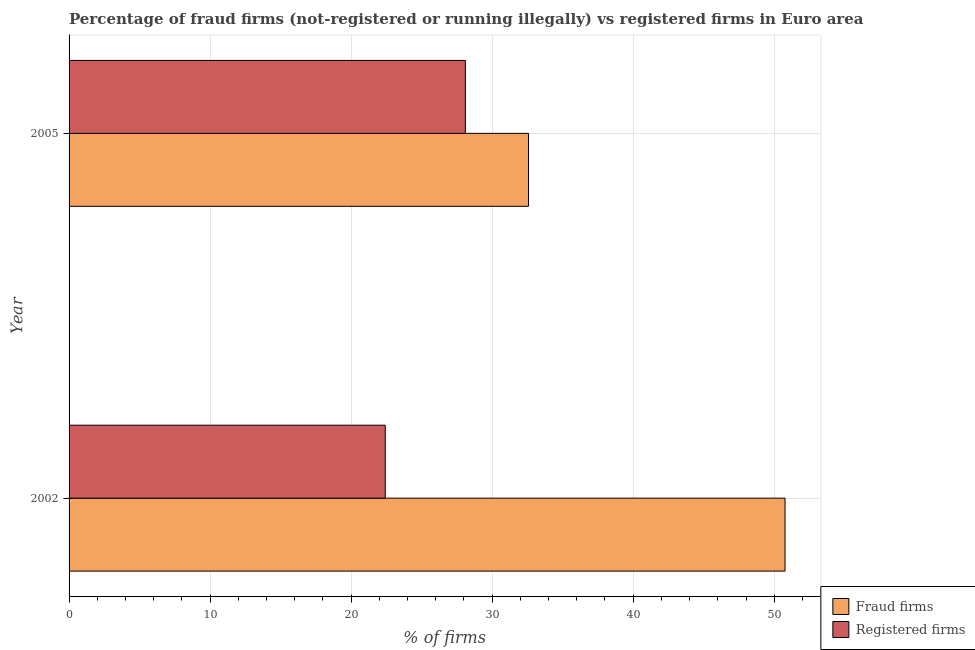How many groups of bars are there?
Give a very brief answer. 2. How many bars are there on the 1st tick from the bottom?
Provide a short and direct response. 2. In how many cases, is the number of bars for a given year not equal to the number of legend labels?
Provide a succinct answer. 0. What is the percentage of fraud firms in 2002?
Offer a very short reply. 50.77. Across all years, what is the maximum percentage of fraud firms?
Provide a succinct answer. 50.77. Across all years, what is the minimum percentage of fraud firms?
Ensure brevity in your answer.  32.58. In which year was the percentage of registered firms maximum?
Your response must be concise. 2005. What is the total percentage of registered firms in the graph?
Ensure brevity in your answer.  50.52. What is the difference between the percentage of registered firms in 2002 and that in 2005?
Ensure brevity in your answer.  -5.68. What is the difference between the percentage of fraud firms in 2002 and the percentage of registered firms in 2005?
Provide a short and direct response. 22.67. What is the average percentage of registered firms per year?
Provide a short and direct response. 25.26. In the year 2005, what is the difference between the percentage of fraud firms and percentage of registered firms?
Your answer should be very brief. 4.48. What is the ratio of the percentage of registered firms in 2002 to that in 2005?
Offer a very short reply. 0.8. Is the difference between the percentage of registered firms in 2002 and 2005 greater than the difference between the percentage of fraud firms in 2002 and 2005?
Offer a terse response. No. In how many years, is the percentage of registered firms greater than the average percentage of registered firms taken over all years?
Your answer should be compact. 1. What does the 1st bar from the top in 2005 represents?
Give a very brief answer. Registered firms. What does the 1st bar from the bottom in 2002 represents?
Offer a terse response. Fraud firms. Are all the bars in the graph horizontal?
Offer a very short reply. Yes. What is the difference between two consecutive major ticks on the X-axis?
Keep it short and to the point. 10. Are the values on the major ticks of X-axis written in scientific E-notation?
Keep it short and to the point. No. Where does the legend appear in the graph?
Keep it short and to the point. Bottom right. How many legend labels are there?
Make the answer very short. 2. What is the title of the graph?
Your answer should be compact. Percentage of fraud firms (not-registered or running illegally) vs registered firms in Euro area. What is the label or title of the X-axis?
Provide a succinct answer. % of firms. What is the % of firms of Fraud firms in 2002?
Your response must be concise. 50.77. What is the % of firms in Registered firms in 2002?
Your answer should be compact. 22.42. What is the % of firms of Fraud firms in 2005?
Your answer should be compact. 32.58. What is the % of firms of Registered firms in 2005?
Your response must be concise. 28.1. Across all years, what is the maximum % of firms in Fraud firms?
Your answer should be very brief. 50.77. Across all years, what is the maximum % of firms of Registered firms?
Provide a succinct answer. 28.1. Across all years, what is the minimum % of firms of Fraud firms?
Keep it short and to the point. 32.58. Across all years, what is the minimum % of firms in Registered firms?
Provide a succinct answer. 22.42. What is the total % of firms in Fraud firms in the graph?
Offer a very short reply. 83.35. What is the total % of firms of Registered firms in the graph?
Give a very brief answer. 50.52. What is the difference between the % of firms of Fraud firms in 2002 and that in 2005?
Keep it short and to the point. 18.19. What is the difference between the % of firms in Registered firms in 2002 and that in 2005?
Keep it short and to the point. -5.68. What is the difference between the % of firms in Fraud firms in 2002 and the % of firms in Registered firms in 2005?
Offer a terse response. 22.67. What is the average % of firms of Fraud firms per year?
Offer a very short reply. 41.67. What is the average % of firms of Registered firms per year?
Your answer should be very brief. 25.26. In the year 2002, what is the difference between the % of firms of Fraud firms and % of firms of Registered firms?
Your answer should be very brief. 28.35. In the year 2005, what is the difference between the % of firms of Fraud firms and % of firms of Registered firms?
Offer a very short reply. 4.48. What is the ratio of the % of firms in Fraud firms in 2002 to that in 2005?
Your answer should be very brief. 1.56. What is the ratio of the % of firms in Registered firms in 2002 to that in 2005?
Make the answer very short. 0.8. What is the difference between the highest and the second highest % of firms of Fraud firms?
Provide a succinct answer. 18.19. What is the difference between the highest and the second highest % of firms in Registered firms?
Your response must be concise. 5.68. What is the difference between the highest and the lowest % of firms of Fraud firms?
Make the answer very short. 18.19. What is the difference between the highest and the lowest % of firms of Registered firms?
Offer a terse response. 5.68. 